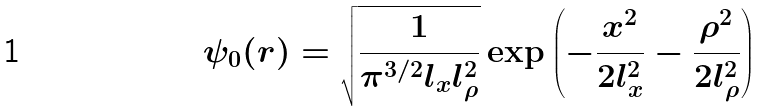<formula> <loc_0><loc_0><loc_500><loc_500>\psi _ { 0 } ( r ) = \sqrt { \frac { 1 } { \pi ^ { 3 / 2 } l _ { x } l ^ { 2 } _ { \rho } } } \exp \left ( - \frac { x ^ { 2 } } { 2 l _ { x } ^ { 2 } } - \frac { \rho ^ { 2 } } { 2 l _ { \rho } ^ { 2 } } \right )</formula> 